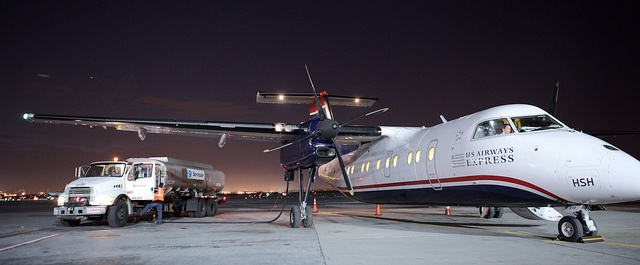Describe the objects in this image and their specific colors. I can see airplane in black, lavender, darkgray, and gray tones, truck in black, white, gray, and darkgray tones, people in black, blue, darkblue, and orange tones, and people in black, pink, gray, and darkgray tones in this image. 